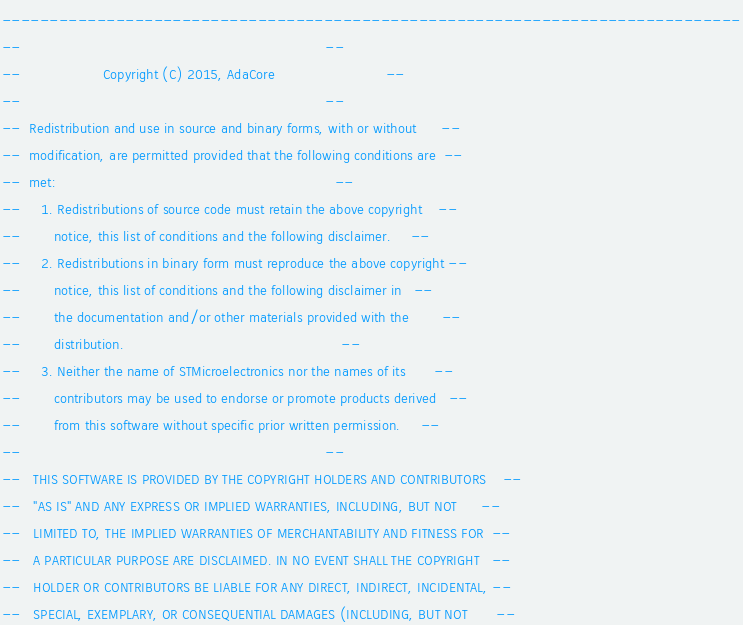<code> <loc_0><loc_0><loc_500><loc_500><_Ada_>------------------------------------------------------------------------------
--                                                                          --
--                    Copyright (C) 2015, AdaCore                           --
--                                                                          --
--  Redistribution and use in source and binary forms, with or without      --
--  modification, are permitted provided that the following conditions are  --
--  met:                                                                    --
--     1. Redistributions of source code must retain the above copyright    --
--        notice, this list of conditions and the following disclaimer.     --
--     2. Redistributions in binary form must reproduce the above copyright --
--        notice, this list of conditions and the following disclaimer in   --
--        the documentation and/or other materials provided with the        --
--        distribution.                                                     --
--     3. Neither the name of STMicroelectronics nor the names of its       --
--        contributors may be used to endorse or promote products derived   --
--        from this software without specific prior written permission.     --
--                                                                          --
--   THIS SOFTWARE IS PROVIDED BY THE COPYRIGHT HOLDERS AND CONTRIBUTORS    --
--   "AS IS" AND ANY EXPRESS OR IMPLIED WARRANTIES, INCLUDING, BUT NOT      --
--   LIMITED TO, THE IMPLIED WARRANTIES OF MERCHANTABILITY AND FITNESS FOR  --
--   A PARTICULAR PURPOSE ARE DISCLAIMED. IN NO EVENT SHALL THE COPYRIGHT   --
--   HOLDER OR CONTRIBUTORS BE LIABLE FOR ANY DIRECT, INDIRECT, INCIDENTAL, --
--   SPECIAL, EXEMPLARY, OR CONSEQUENTIAL DAMAGES (INCLUDING, BUT NOT       --</code> 